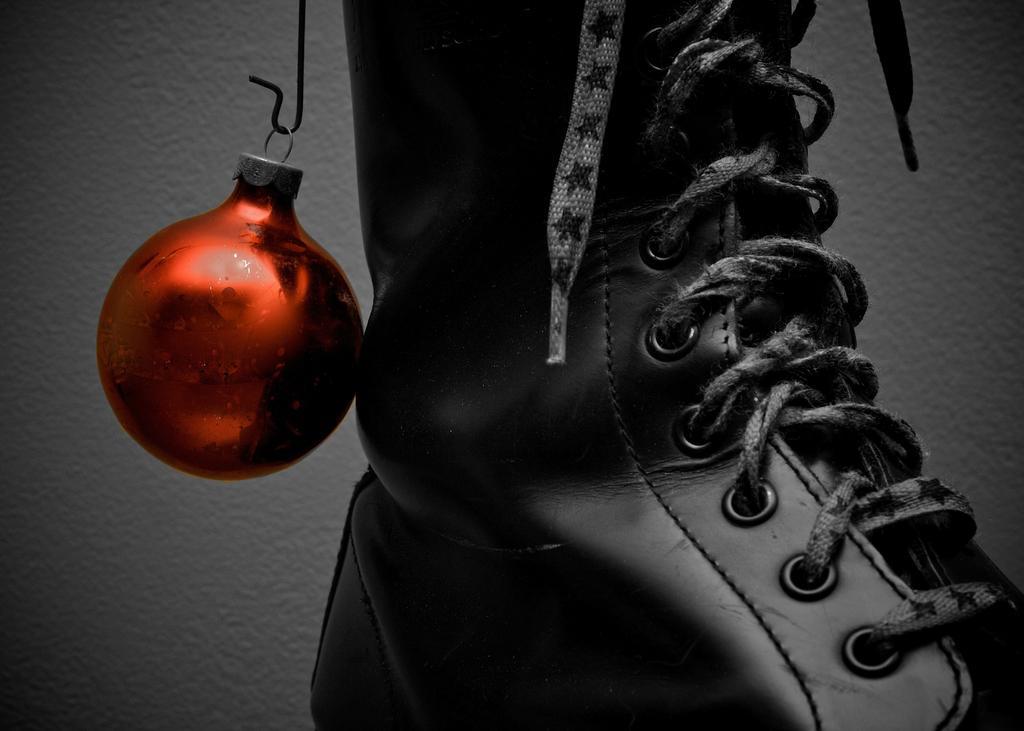Describe this image in one or two sentences. In this image we can see a shoe and a ball with ring placed on a hook. 